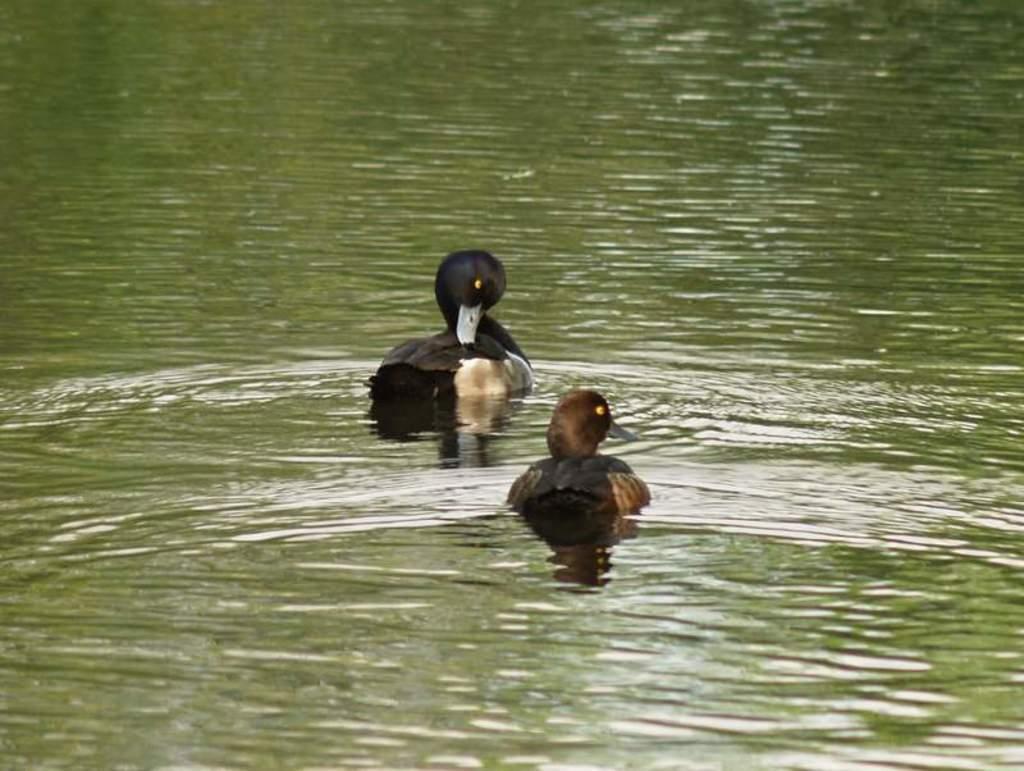Can you describe this image briefly? In this picture we can see two ducks on the water. 